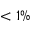<formula> <loc_0><loc_0><loc_500><loc_500>< 1 \%</formula> 